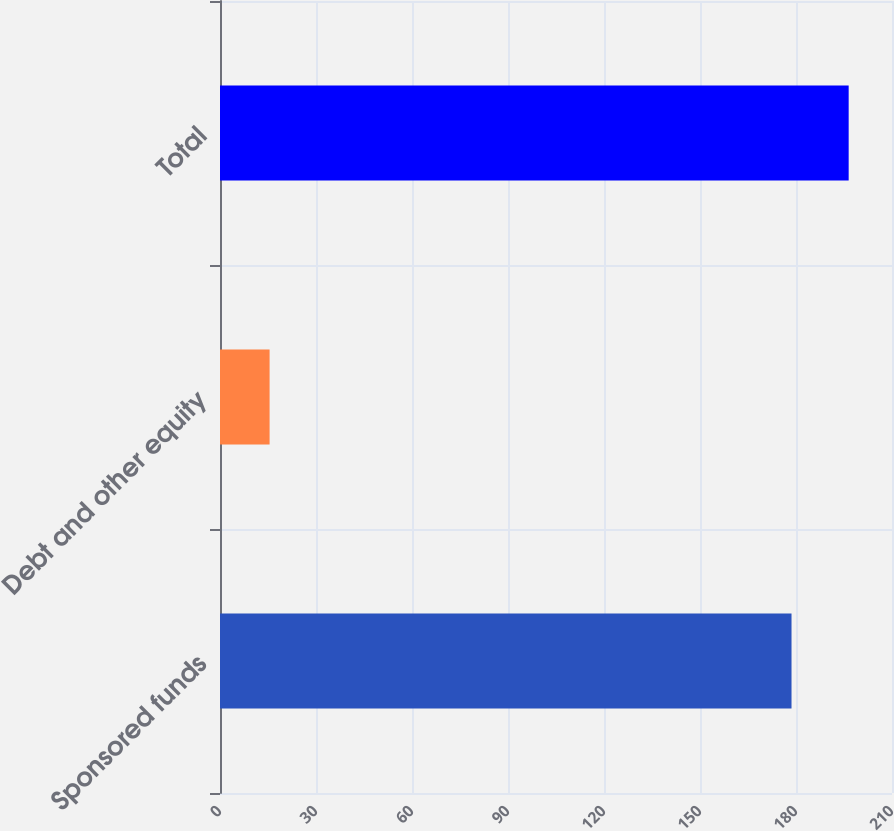Convert chart to OTSL. <chart><loc_0><loc_0><loc_500><loc_500><bar_chart><fcel>Sponsored funds<fcel>Debt and other equity<fcel>Total<nl><fcel>178.6<fcel>15.5<fcel>196.46<nl></chart> 